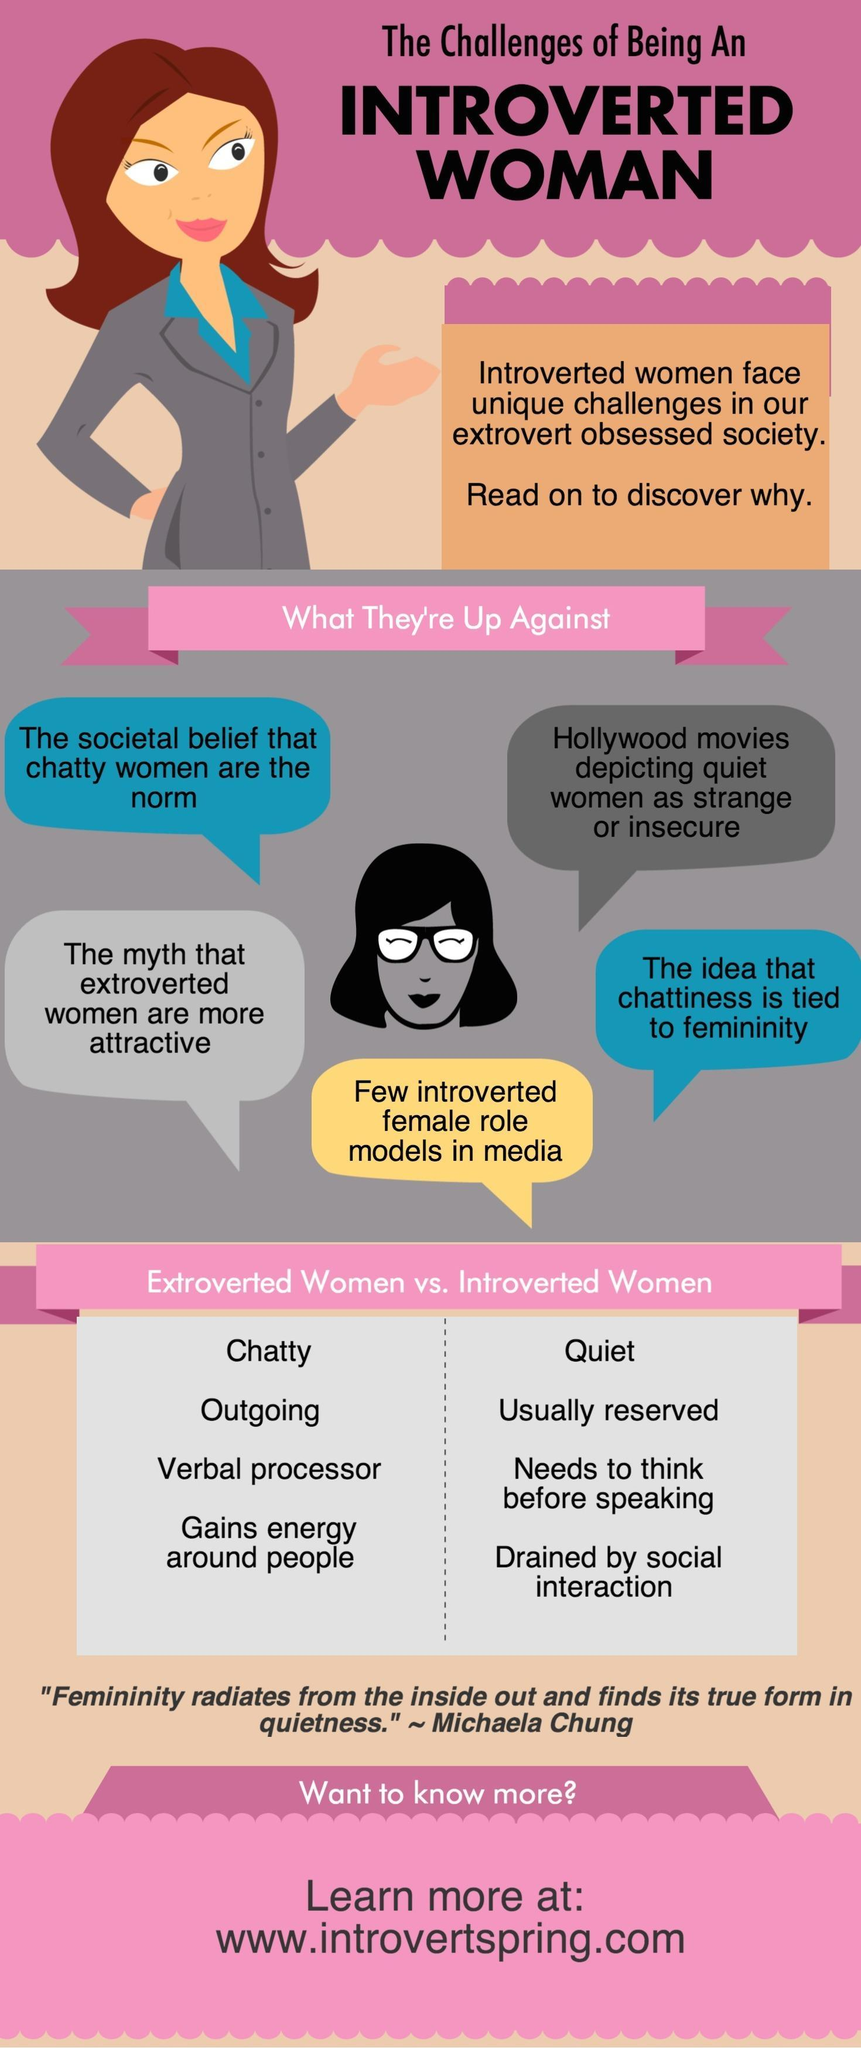Which difficulty faced by an introspective woman is given in yellow background color?
Answer the question with a short phrase. Few introverted female role models in media Chatty, Outgoing, etc are the characteristics of which type of personality? extroverted How many difficulties in blue background color given in the infographic? 2 